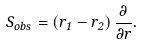<formula> <loc_0><loc_0><loc_500><loc_500>S _ { o b s } = \left ( r _ { 1 } - r _ { 2 } \right ) \frac { \partial } { \partial r } .</formula> 